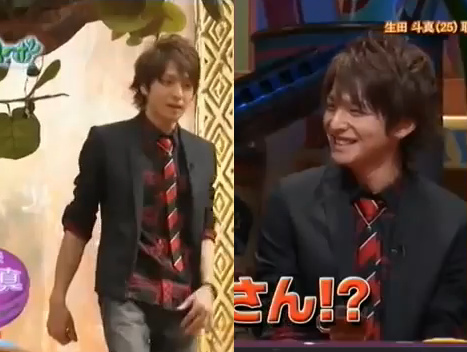Who is wearing the necklace? The man is wearing the necklace. 